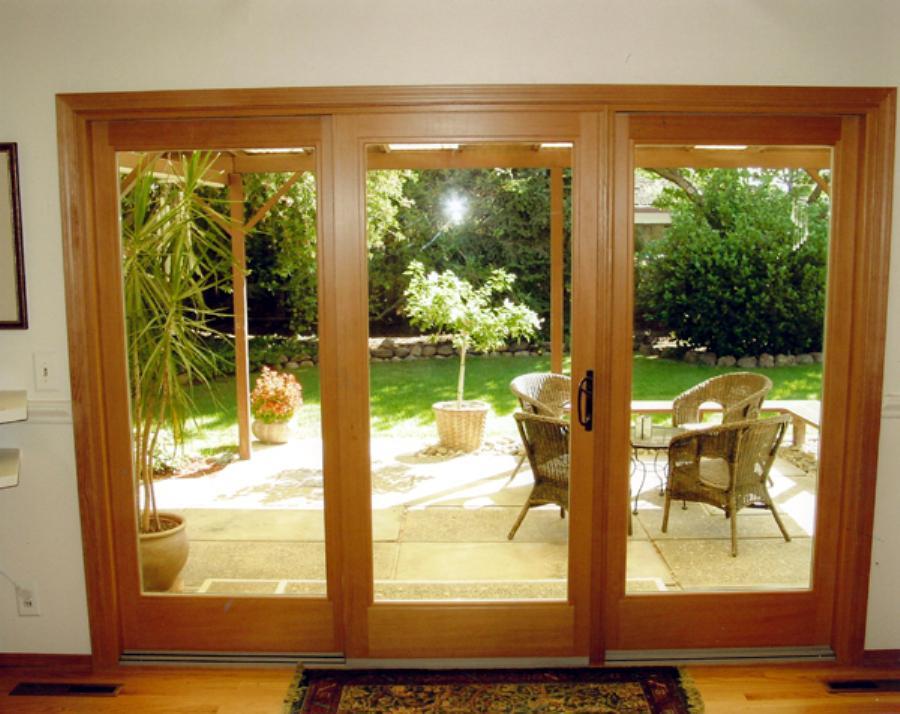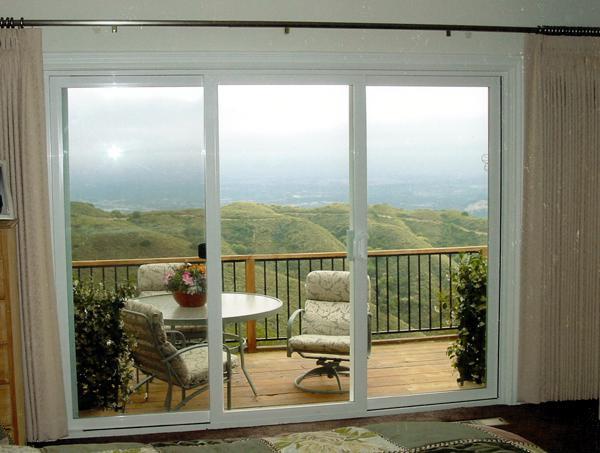The first image is the image on the left, the second image is the image on the right. Given the left and right images, does the statement "Both sets of doors in the images are white." hold true? Answer yes or no. No. The first image is the image on the left, the second image is the image on the right. Given the left and right images, does the statement "An image shows a row of hinged glass panels forming an accordion-like pattern." hold true? Answer yes or no. No. 